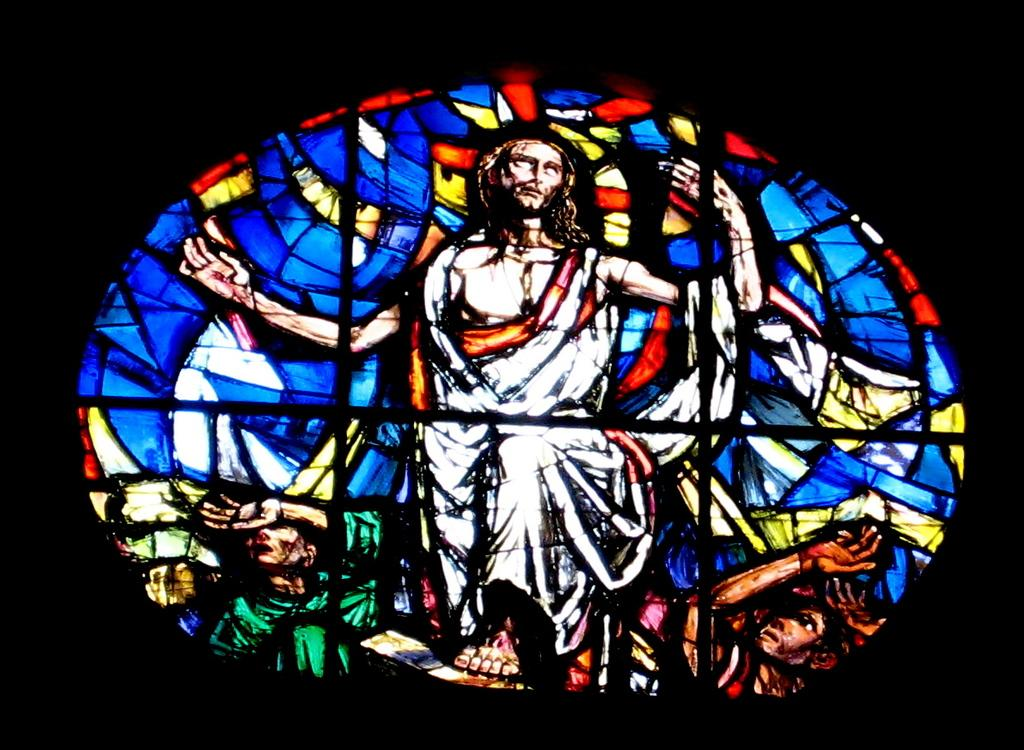What is the main object in the image? There is an object with a painting in the image. What is shown in the painting? The painting depicts three persons. How are the three persons in the painting different from each other? The three persons are in different colors. How many badges are visible on the persons in the painting? There are no badges visible on the persons in the painting; they are depicted in different colors. What type of pizzas are being served by the secretary in the image? There is no secretary or pizzas present in the image. 